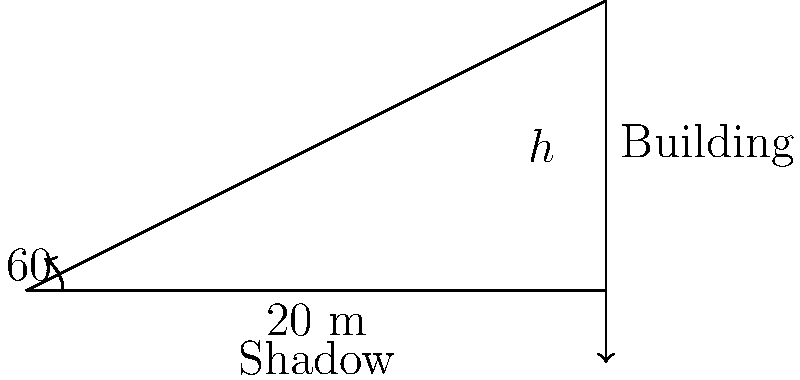As an entrepreneur planning to construct a multi-story commercial complex in a Tier 2 city, you need to estimate the height of a neighboring building. On a sunny day, you measure the shadow of the building to be 20 meters long. If the angle of elevation of the sun is 60°, what is the height of the building? Let's approach this step-by-step:

1) In this problem, we have a right-angled triangle where:
   - The shadow length is the base of the triangle
   - The building height is the perpendicular side
   - The sun's rays form the hypotenuse

2) We know:
   - The angle of elevation (angle between the ground and sun's rays) is 60°
   - The length of the shadow (base of the triangle) is 20 meters

3) We need to find the height of the building, which is the opposite side to the 60° angle.

4) In a right-angled triangle, tangent of an angle is the ratio of the opposite side to the adjacent side:

   $\tan \theta = \frac{\text{opposite}}{\text{adjacent}}$

5) In our case:
   $\tan 60° = \frac{\text{height}}{\text{shadow length}}$

6) We know that $\tan 60° = \sqrt{3}$, so:

   $\sqrt{3} = \frac{\text{height}}{20}$

7) Solving for height:
   $\text{height} = 20 \sqrt{3}$

8) To get a decimal approximation:
   $\text{height} \approx 20 \times 1.732 \approx 34.64$ meters

Therefore, the height of the building is $20\sqrt{3}$ meters or approximately 34.64 meters.
Answer: $20\sqrt{3}$ meters 